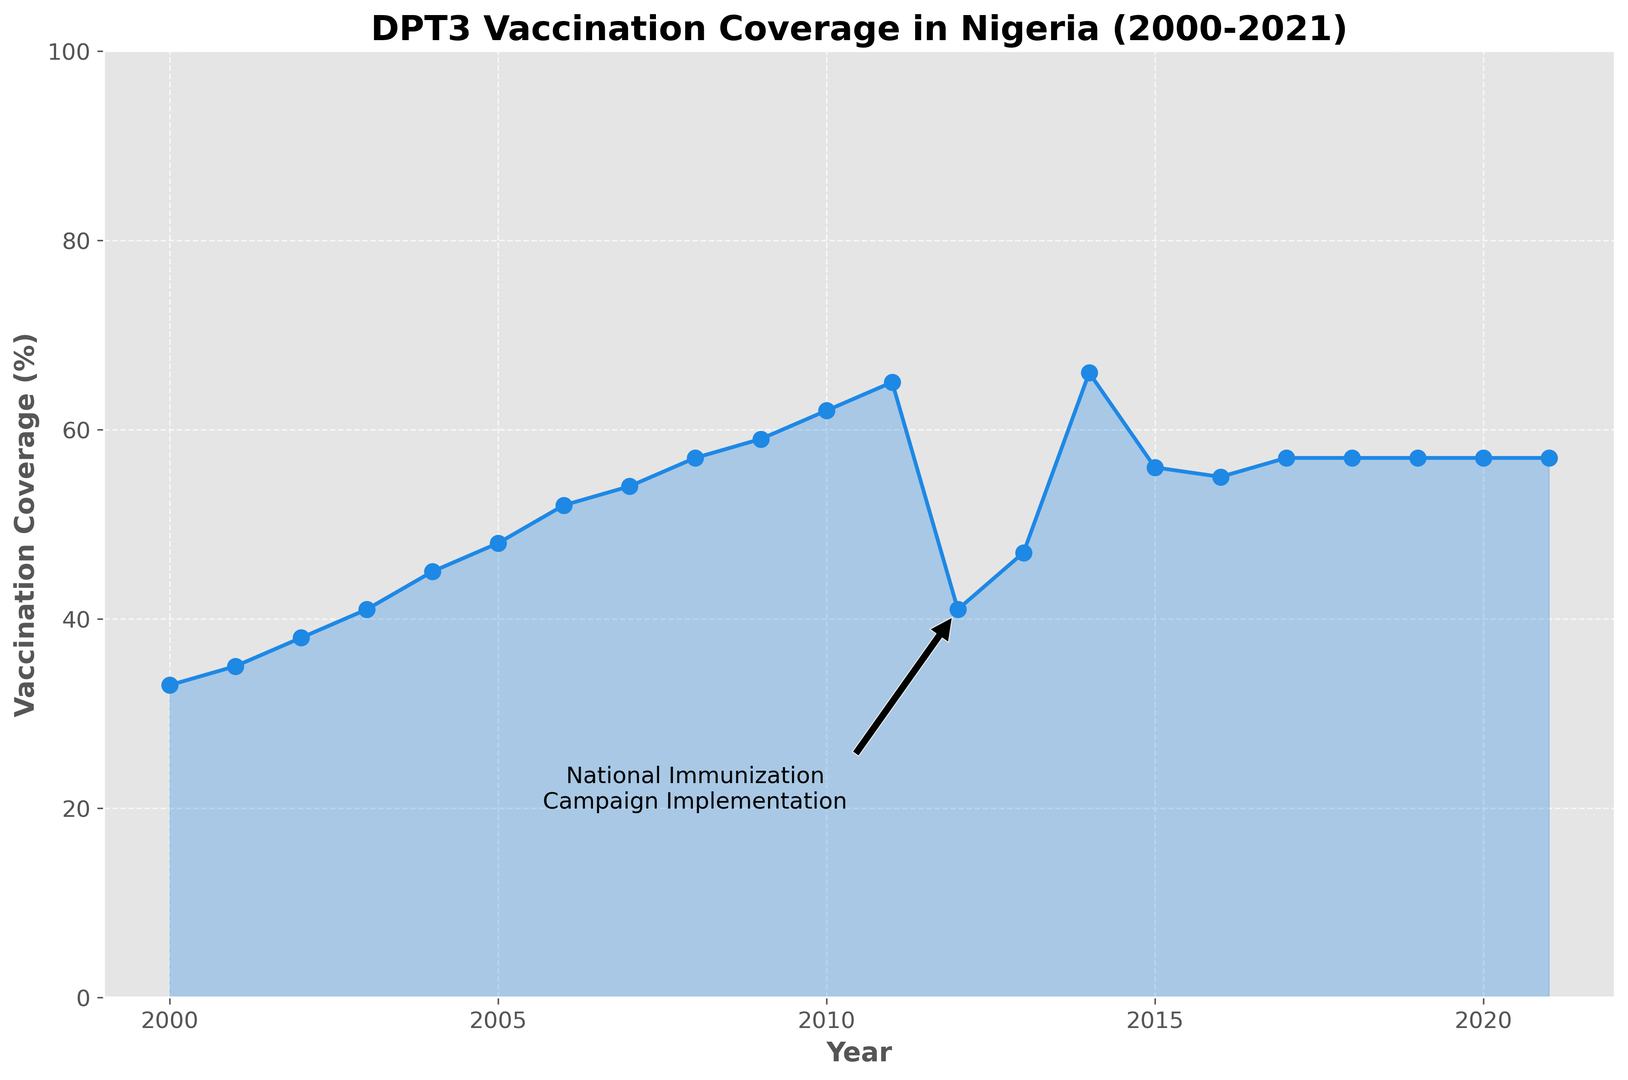What trend in DPT3 vaccination coverage can be observed from 2000 to 2021? DPT3 vaccination coverage shows an overall increasing trend from 2000 to 2021, starting at 33% in 2000 and reaching 57% in 2021.
Answer: Increasing trend When was the National Immunization Campaign implemented, and what was the immediate effect on vaccination coverage? The National Immunization Campaign was implemented in 2012, and the vaccination coverage dropped from ~62% in 2011 to 41% in 2012.
Answer: 2012, immediate drop What is the highest recorded DPT3 vaccination coverage and in which year was it achieved? The highest recorded DPT3 vaccination coverage was 66%, achieved in 2014.
Answer: 66%, 2014 How did the DPT3 vaccination coverage change from 2019 to 2021? The coverage remained steady at 57% from 2019 to 2021.
Answer: Remained steady What was the overall percentage increase in vaccination coverage from 2000 to 2010? The coverage increased from 33% in 2000 to 62% in 2010. The overall increase is 62% - 33% = 29%.
Answer: 29% How does the DPT3 vaccination coverage in 2005 compare to that in 2006? The coverage increased from 48% in 2005 to 52% in 2006.
Answer: Increased by 4% What percentage of drop in vaccination coverage occurred from 2011 to 2012? The coverage dropped from ~62% in 2011 to 41% in 2012. The drop is approximately 62% - 41% = 21%.
Answer: 21% What happens to the trend in vaccination coverage after the implementation of the National Immunization Campaign in 2012? After the drop in 2012, the coverage rose again to 47% in 2013 and peaked at 66% in 2014 before stabilizing around 57% in later years.
Answer: Increased, peaked, stabilized How does the coverage in 2005 compare to the coverage in 2010? The coverage increased from 48% in 2005 to 62% in 2010.
Answer: Increased by 14% What visual element in the figure indicates the approximate date of the National Immunization Campaign implementation? An annotation with an arrow pointing to 2012 and labeled "National Immunization Campaign Implementation" indicates this date.
Answer: Annotation pointing to 2012 